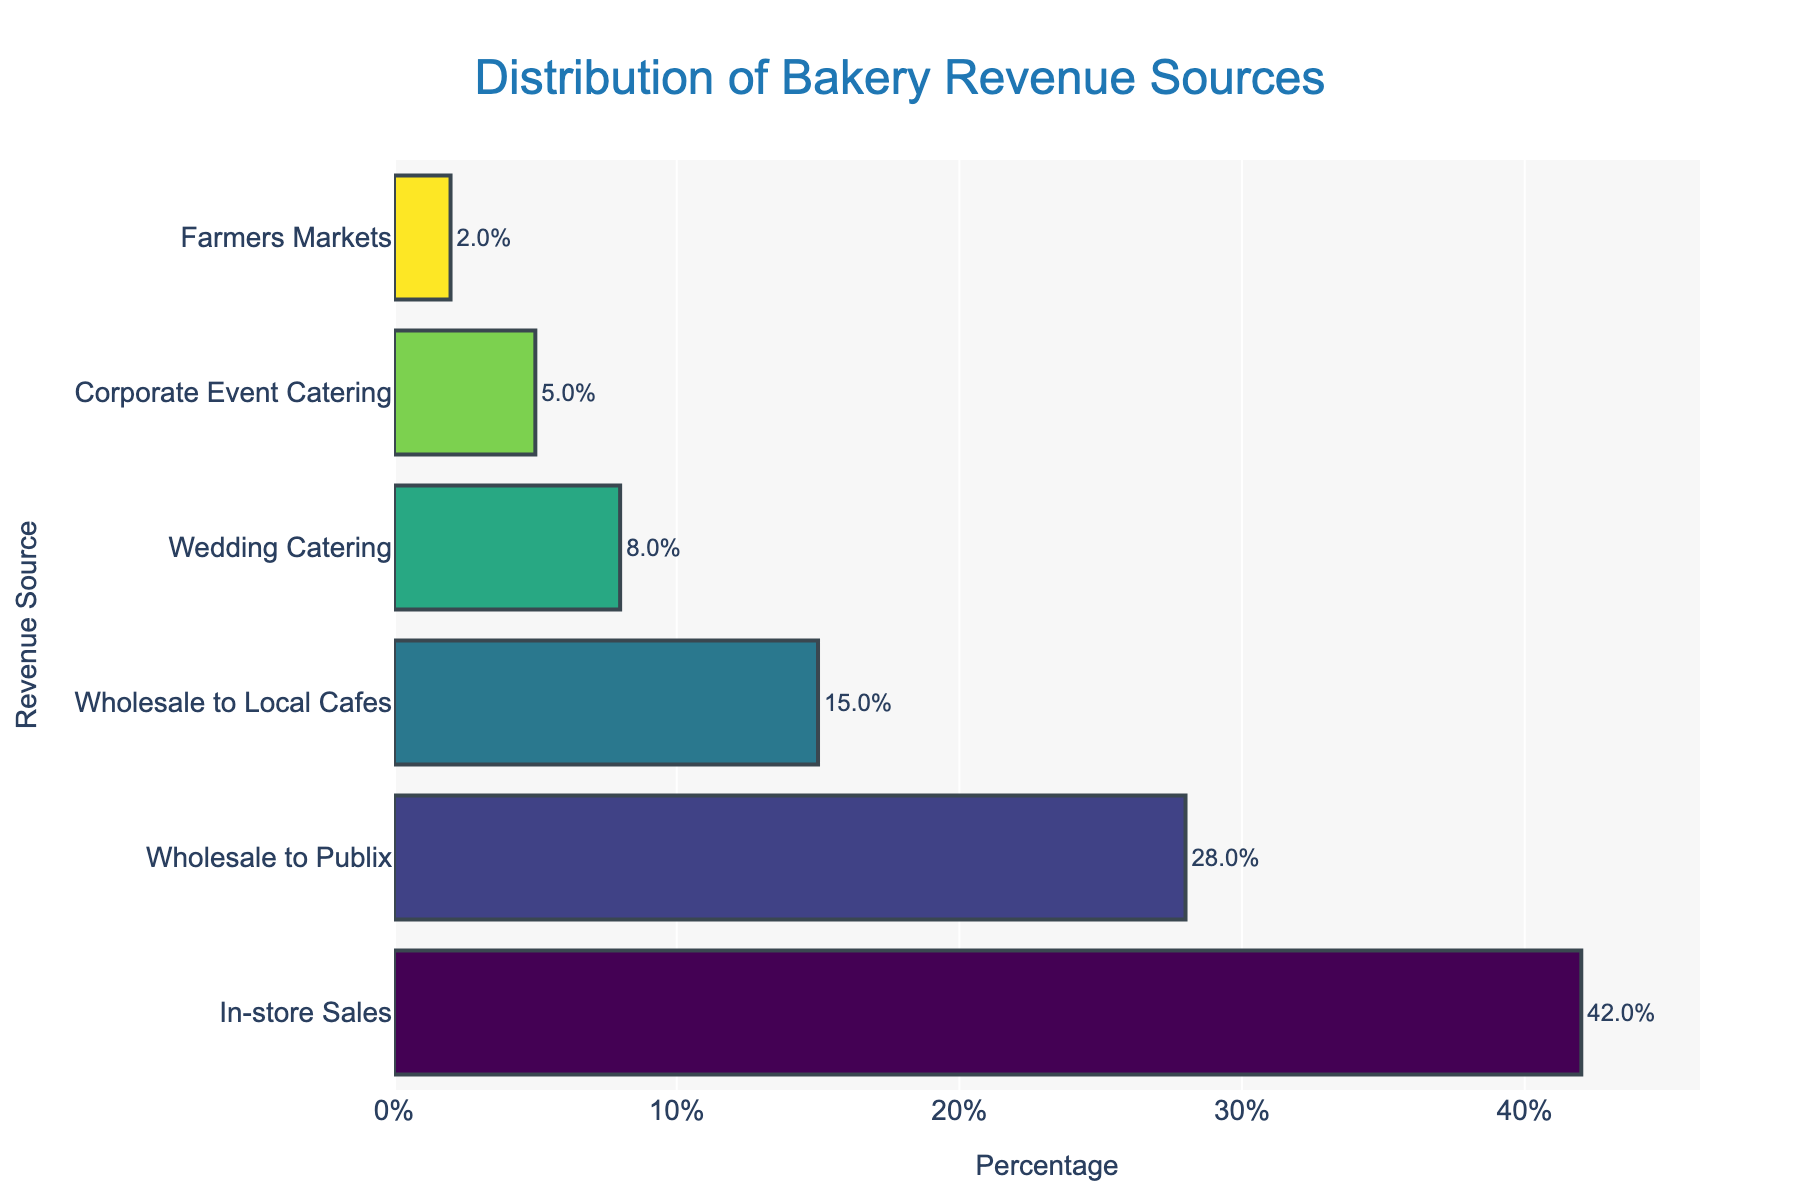What revenue source contributes the most to the bakery's revenue? The bar representing in-store sales is the longest, indicating it has the highest percentage among all revenue sources.
Answer: In-store Sales Which revenue source has a higher percentage: wholesale to Publix or wholesale to local cafes? Comparing the bar lengths, the bar for wholesale to Publix is longer than the bar for wholesale to local cafes, indicating a higher percentage.
Answer: Wholesale to Publix What's the combined percentage of the catering revenue sources (wedding catering and corporate event catering)? Sum the percentages of wedding catering (8%) and corporate event catering (5%): 8 + 5 = 13
Answer: 13% Is the percentage of in-store sales more than double the percentage of wholesale to local cafes? Compare the percentage of in-store sales (42%) to double the percentage of wholesale to local cafes (2 * 15% = 30%). Since 42% > 30%, the in-store sales percentage is more than double.
Answer: Yes Which revenue source contributes the least to the bakery's revenue? The bar representing farmers markets is the shortest, indicating it has the lowest percentage among all revenue sources.
Answer: Farmers Markets How much higher is the percentage of wholesale to Publix compared to corporate event catering? Subtract the percentage of corporate event catering (5%) from the percentage of wholesale to Publix (28%): 28 - 5 = 23
Answer: 23% What percent of the bakery's revenue comes from wholesale (to Publix and local cafes)? Sum the percentages of wholesale to Publix (28%) and wholesale to local cafes (15%): 28 + 15 = 43
Answer: 43% Which has a longer bar: wholesale to local cafes or wedding catering? The bar for wholesale to local cafes is longer than the bar for wedding catering, indicating a higher percentage.
Answer: Wholesale to Local Cafes If in-store sales are represented in green, which color is used for corporate event catering? Visual inspection indicates that corporate event catering is depicted in a certain color. Since each bar has a different color, determine visually the bar color for corporate event catering.
Answer: Answer based on figure Does the combined revenue from wedding catering and corporate event catering surpass wholesale to Publix alone? Combine the percentages of wedding catering and corporate event catering (8% + 5% = 13%) and compare it to wholesale to Publix (28%). Since 13% < 28%, it does not surpass.
Answer: No 